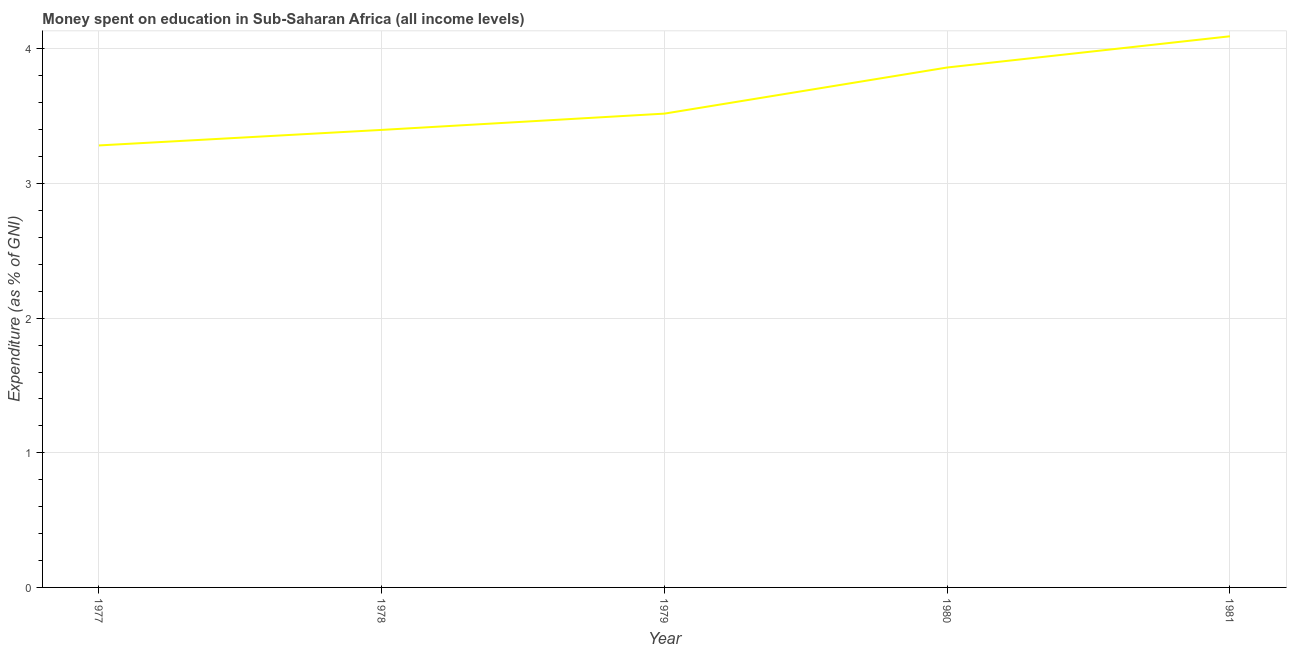What is the expenditure on education in 1981?
Keep it short and to the point. 4.09. Across all years, what is the maximum expenditure on education?
Offer a terse response. 4.09. Across all years, what is the minimum expenditure on education?
Provide a succinct answer. 3.28. In which year was the expenditure on education minimum?
Your answer should be very brief. 1977. What is the sum of the expenditure on education?
Provide a short and direct response. 18.16. What is the difference between the expenditure on education in 1979 and 1981?
Provide a succinct answer. -0.57. What is the average expenditure on education per year?
Your answer should be compact. 3.63. What is the median expenditure on education?
Provide a succinct answer. 3.52. In how many years, is the expenditure on education greater than 2.6 %?
Ensure brevity in your answer.  5. Do a majority of the years between 1977 and 1981 (inclusive) have expenditure on education greater than 0.2 %?
Offer a terse response. Yes. What is the ratio of the expenditure on education in 1977 to that in 1981?
Your answer should be very brief. 0.8. Is the difference between the expenditure on education in 1978 and 1980 greater than the difference between any two years?
Your answer should be very brief. No. What is the difference between the highest and the second highest expenditure on education?
Ensure brevity in your answer.  0.23. What is the difference between the highest and the lowest expenditure on education?
Your answer should be very brief. 0.81. In how many years, is the expenditure on education greater than the average expenditure on education taken over all years?
Provide a short and direct response. 2. Does the expenditure on education monotonically increase over the years?
Keep it short and to the point. Yes. How many lines are there?
Offer a terse response. 1. How many years are there in the graph?
Offer a very short reply. 5. Are the values on the major ticks of Y-axis written in scientific E-notation?
Provide a succinct answer. No. Does the graph contain any zero values?
Offer a terse response. No. Does the graph contain grids?
Ensure brevity in your answer.  Yes. What is the title of the graph?
Your answer should be compact. Money spent on education in Sub-Saharan Africa (all income levels). What is the label or title of the Y-axis?
Make the answer very short. Expenditure (as % of GNI). What is the Expenditure (as % of GNI) in 1977?
Provide a succinct answer. 3.28. What is the Expenditure (as % of GNI) in 1978?
Offer a very short reply. 3.4. What is the Expenditure (as % of GNI) in 1979?
Provide a succinct answer. 3.52. What is the Expenditure (as % of GNI) of 1980?
Provide a succinct answer. 3.86. What is the Expenditure (as % of GNI) of 1981?
Give a very brief answer. 4.09. What is the difference between the Expenditure (as % of GNI) in 1977 and 1978?
Provide a short and direct response. -0.12. What is the difference between the Expenditure (as % of GNI) in 1977 and 1979?
Keep it short and to the point. -0.24. What is the difference between the Expenditure (as % of GNI) in 1977 and 1980?
Your answer should be very brief. -0.58. What is the difference between the Expenditure (as % of GNI) in 1977 and 1981?
Provide a short and direct response. -0.81. What is the difference between the Expenditure (as % of GNI) in 1978 and 1979?
Give a very brief answer. -0.12. What is the difference between the Expenditure (as % of GNI) in 1978 and 1980?
Ensure brevity in your answer.  -0.46. What is the difference between the Expenditure (as % of GNI) in 1978 and 1981?
Provide a short and direct response. -0.7. What is the difference between the Expenditure (as % of GNI) in 1979 and 1980?
Your answer should be very brief. -0.34. What is the difference between the Expenditure (as % of GNI) in 1979 and 1981?
Make the answer very short. -0.57. What is the difference between the Expenditure (as % of GNI) in 1980 and 1981?
Give a very brief answer. -0.23. What is the ratio of the Expenditure (as % of GNI) in 1977 to that in 1979?
Ensure brevity in your answer.  0.93. What is the ratio of the Expenditure (as % of GNI) in 1977 to that in 1981?
Your response must be concise. 0.8. What is the ratio of the Expenditure (as % of GNI) in 1978 to that in 1980?
Ensure brevity in your answer.  0.88. What is the ratio of the Expenditure (as % of GNI) in 1978 to that in 1981?
Provide a succinct answer. 0.83. What is the ratio of the Expenditure (as % of GNI) in 1979 to that in 1980?
Provide a succinct answer. 0.91. What is the ratio of the Expenditure (as % of GNI) in 1979 to that in 1981?
Keep it short and to the point. 0.86. What is the ratio of the Expenditure (as % of GNI) in 1980 to that in 1981?
Provide a succinct answer. 0.94. 